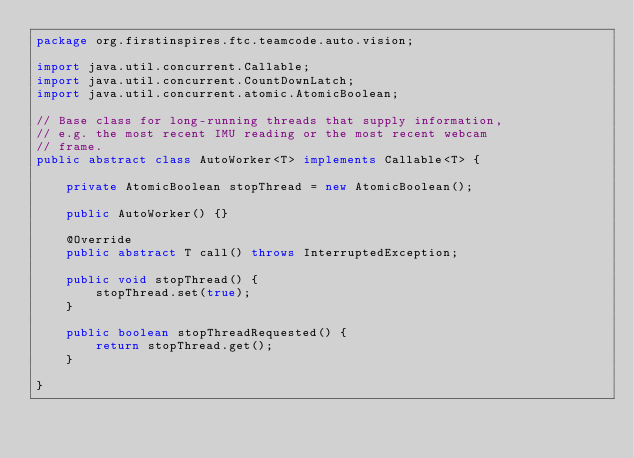Convert code to text. <code><loc_0><loc_0><loc_500><loc_500><_Java_>package org.firstinspires.ftc.teamcode.auto.vision;

import java.util.concurrent.Callable;
import java.util.concurrent.CountDownLatch;
import java.util.concurrent.atomic.AtomicBoolean;

// Base class for long-running threads that supply information,
// e.g. the most recent IMU reading or the most recent webcam
// frame.
public abstract class AutoWorker<T> implements Callable<T> {

    private AtomicBoolean stopThread = new AtomicBoolean();

    public AutoWorker() {}

    @Override
    public abstract T call() throws InterruptedException;

    public void stopThread() {
        stopThread.set(true);
    }

    public boolean stopThreadRequested() {
        return stopThread.get();
    }

}
</code> 